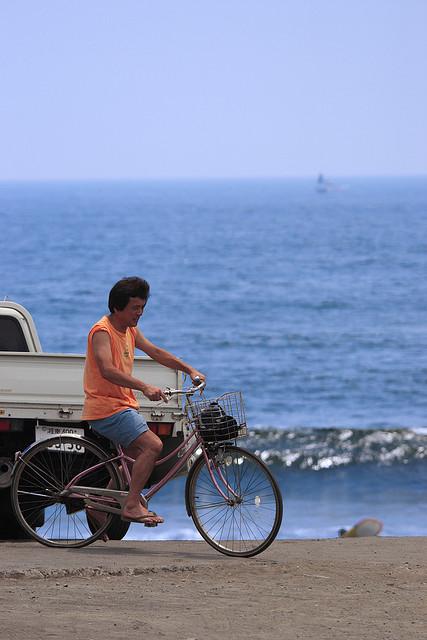Where is the man riding his bike?
Quick response, please. Beach. Is that a man or a woman?
Answer briefly. Man. Is there a boat in the water?
Answer briefly. Yes. 